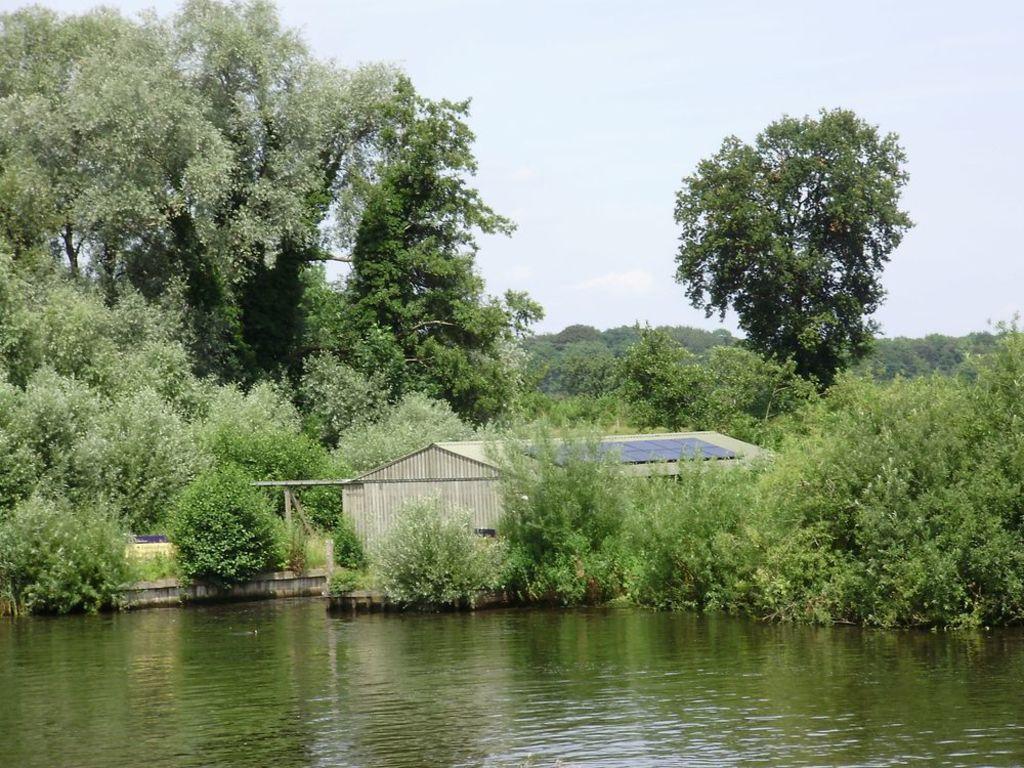Could you give a brief overview of what you see in this image? In this image I can see the water, background I can see the house, trees in green color and the sky is white color. 